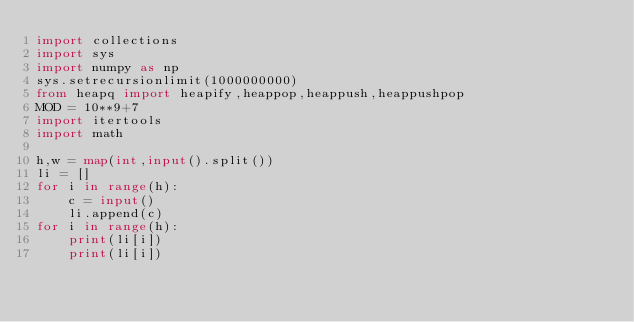Convert code to text. <code><loc_0><loc_0><loc_500><loc_500><_Python_>import collections
import sys
import numpy as np
sys.setrecursionlimit(1000000000)
from heapq import heapify,heappop,heappush,heappushpop
MOD = 10**9+7
import itertools
import math

h,w = map(int,input().split())
li = []
for i in range(h):
    c = input()
    li.append(c)
for i in range(h):
    print(li[i])
    print(li[i])
</code> 